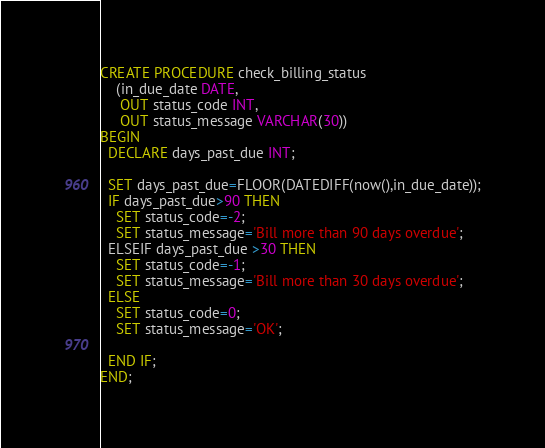<code> <loc_0><loc_0><loc_500><loc_500><_SQL_>CREATE PROCEDURE check_billing_status
    (in_due_date DATE, 
     OUT status_code INT, 
     OUT status_message VARCHAR(30))
BEGIN
  DECLARE days_past_due INT;
   
  SET days_past_due=FLOOR(DATEDIFF(now(),in_due_date));
  IF days_past_due>90 THEN 
    SET status_code=-2;
    SET status_message='Bill more than 90 days overdue';
  ELSEIF days_past_due >30 THEN
    SET status_code=-1;
    SET status_message='Bill more than 30 days overdue';
  ELSE
    SET status_code=0;
    SET status_message='OK';
 
  END IF;
END;
</code> 